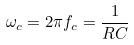Convert formula to latex. <formula><loc_0><loc_0><loc_500><loc_500>\omega _ { c } = 2 \pi f _ { c } = \frac { 1 } { R C }</formula> 